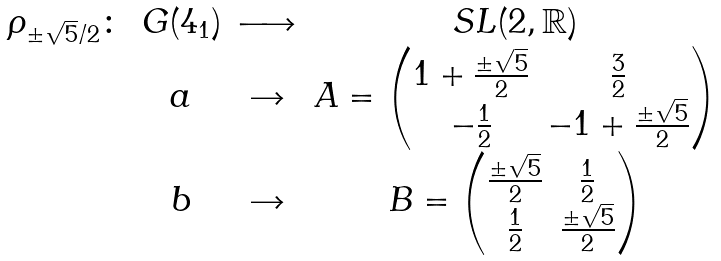<formula> <loc_0><loc_0><loc_500><loc_500>\begin{array} { c c c c } \rho _ { \pm \sqrt { 5 } / 2 } \colon & G ( 4 _ { 1 } ) & \longrightarrow & S L ( 2 , \mathbb { R } ) \\ & a & \rightarrow & A = \begin{pmatrix} 1 + \frac { \pm \sqrt { 5 } } { 2 } & \frac { 3 } { 2 } \\ - \frac { 1 } { 2 } & - 1 + \frac { \pm \sqrt { 5 } } { 2 } \end{pmatrix} \\ & b & \rightarrow & B = \begin{pmatrix} \frac { \pm \sqrt { 5 } } { 2 } & \frac { 1 } { 2 } \\ \frac { 1 } { 2 } & \frac { \pm \sqrt { 5 } } { 2 } \end{pmatrix} \end{array}</formula> 